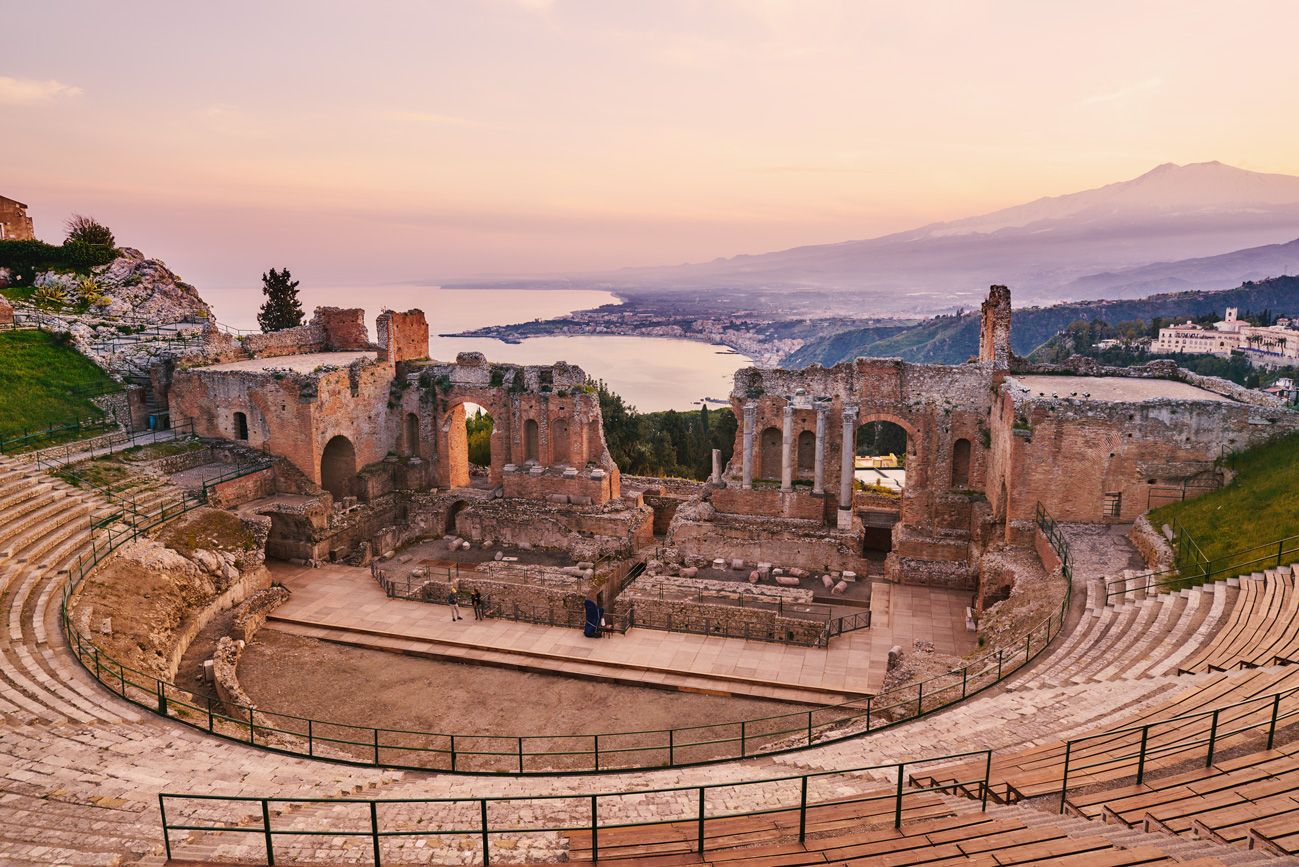What do you think is going on in this snapshot? This image captures the awe-inspiring Greek Theater of Taormina in Sicily, Italy, soaked in the warm hues of a setting sun. Built in the third century BC, this historical amphitheater offers a riveting lesson in ancient Greek architecture, with its semicircular arrangement and open-air design perfectly framing the breathtaking views of Mount Etna and the Ionian Sea. Originally used for dramatic and musical performances, this theater now serves as a silent witness to the passage of millennia, hosting modern audiences for concerts and plays, thereby continuing its legacy as a cultural hub. The visitors you see here are experiencing not just the physical space but also a deep, historical narrative spanning several ages. 